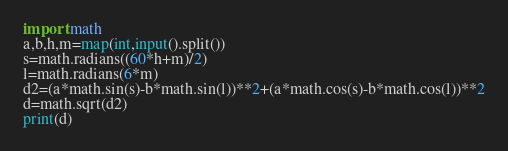<code> <loc_0><loc_0><loc_500><loc_500><_Python_>import math
a,b,h,m=map(int,input().split())
s=math.radians((60*h+m)/2)
l=math.radians(6*m)
d2=(a*math.sin(s)-b*math.sin(l))**2+(a*math.cos(s)-b*math.cos(l))**2
d=math.sqrt(d2)
print(d)</code> 